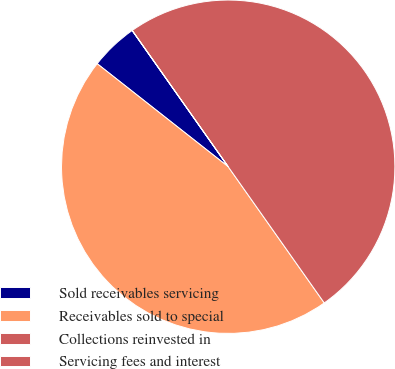Convert chart to OTSL. <chart><loc_0><loc_0><loc_500><loc_500><pie_chart><fcel>Sold receivables servicing<fcel>Receivables sold to special<fcel>Collections reinvested in<fcel>Servicing fees and interest<nl><fcel>4.62%<fcel>45.38%<fcel>49.99%<fcel>0.01%<nl></chart> 